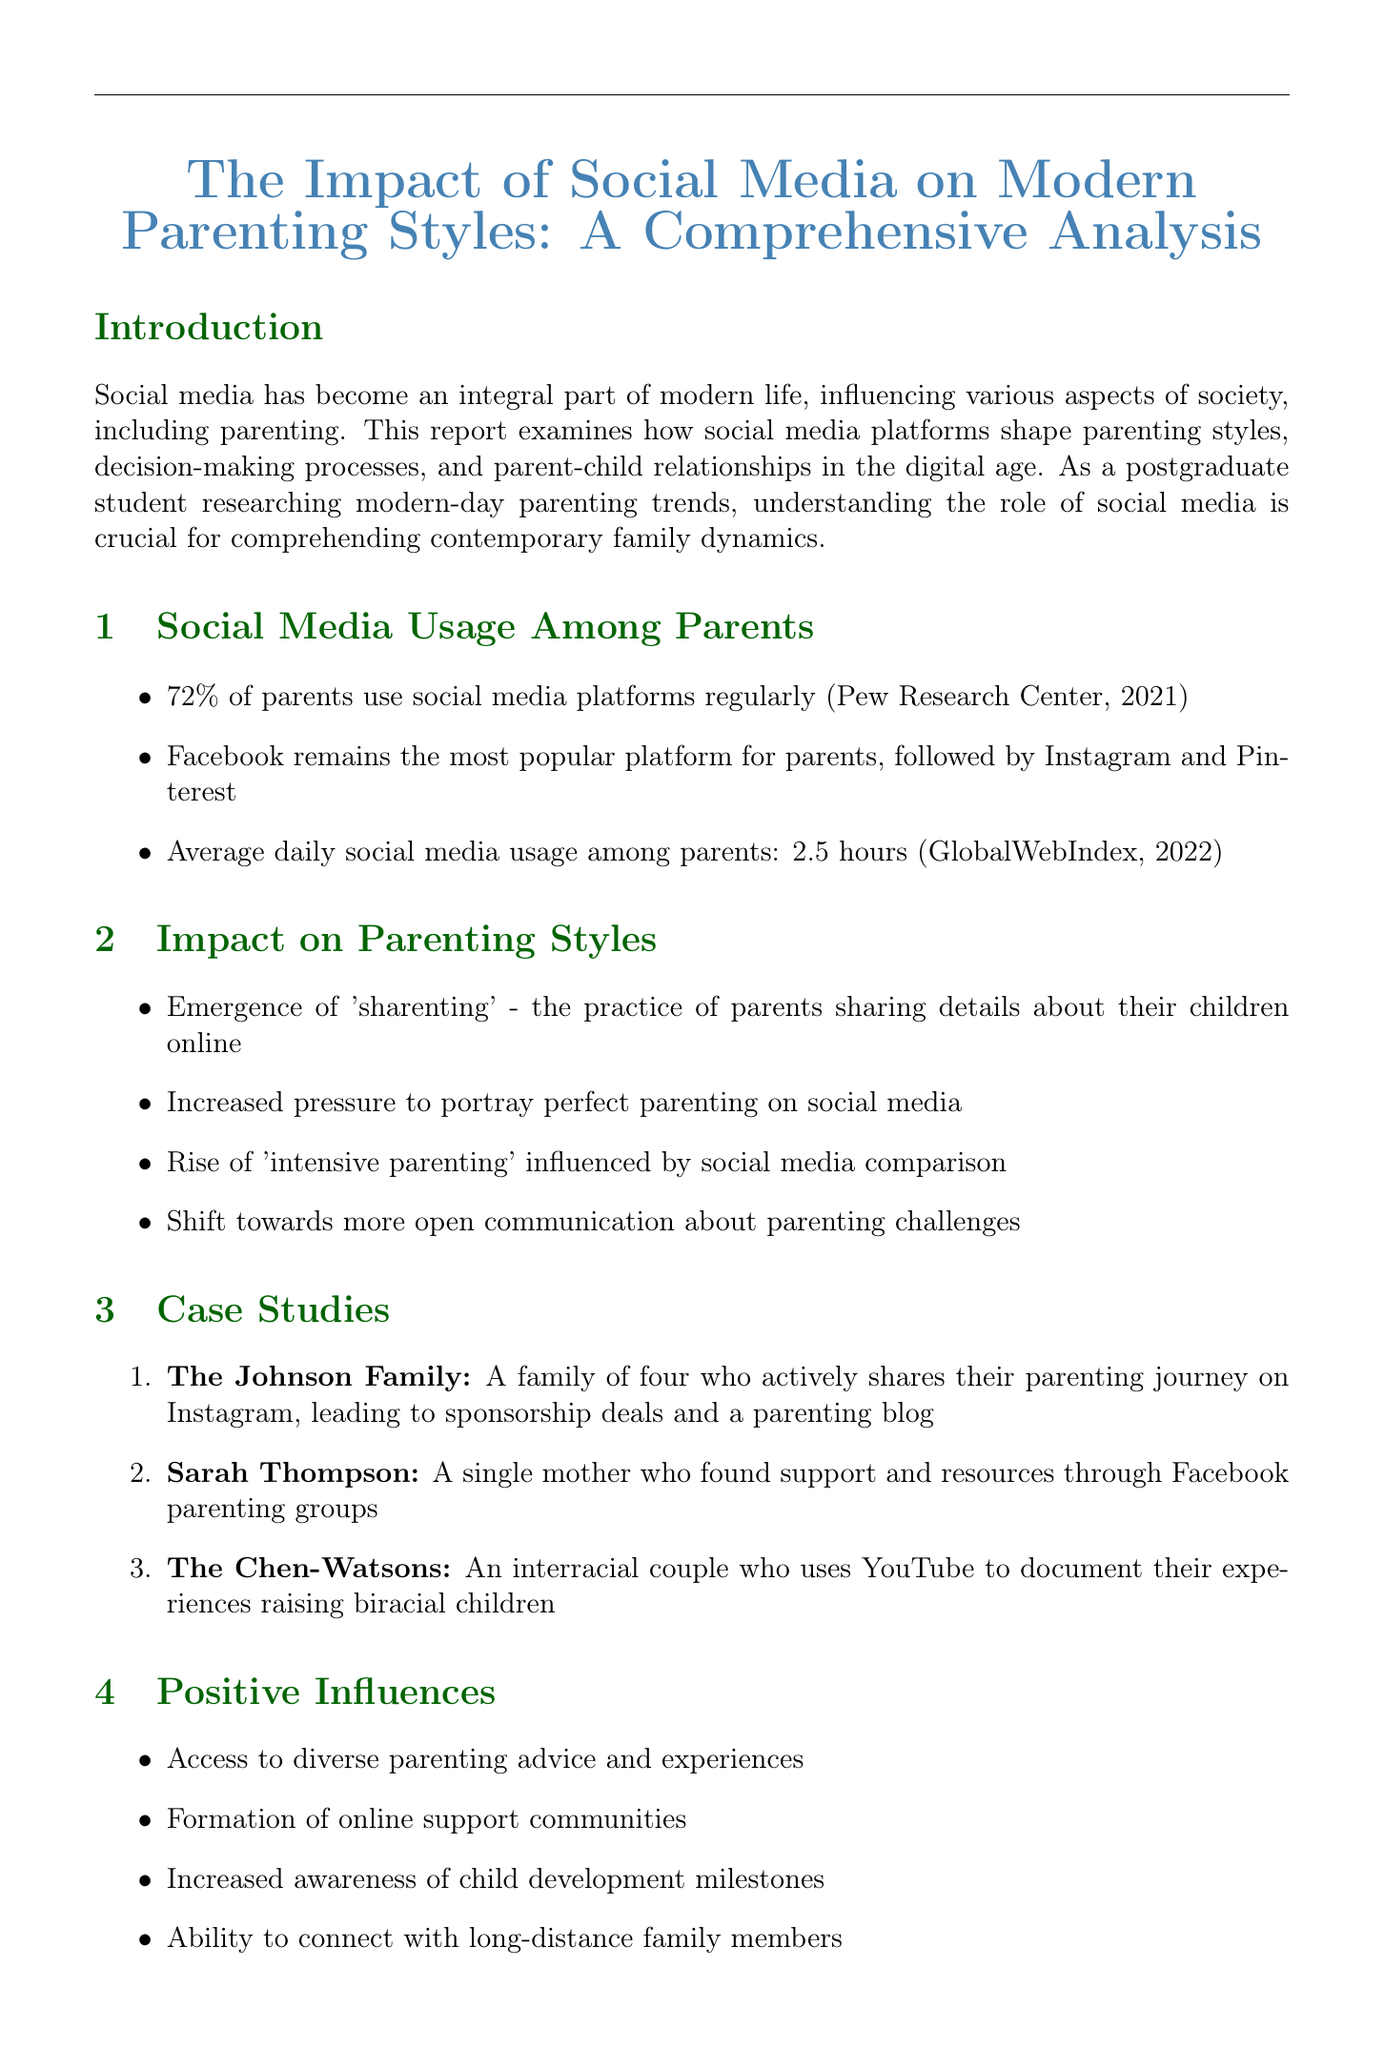What percentage of parents use social media regularly? The report states that 72% of parents use social media platforms regularly according to the Pew Research Center.
Answer: 72% Which social media platform is the most popular among parents? The document mentions that Facebook remains the most popular platform for parents.
Answer: Facebook What is the average daily social media usage among parents? According to the GlobalWebIndex, the average daily usage is 2.5 hours.
Answer: 2.5 hours What percentage of parents feel pressure to present an idealized version of family life online? The OnePoll survey indicates that 42% of parents feel this pressure.
Answer: 42% Who is the expert from Harvard Graduate School of Education quoted in the report? The report features Dr. Emily Weinstein as an expert from Harvard Graduate School of Education.
Answer: Dr. Emily Weinstein What term describes the practice of parents sharing details about their children online? The document refers to this practice as "sharenting."
Answer: sharenting What was the increase in likelihood of parental burnout for frequent social media users? According to the Journal of Social and Personal Relationships, frequent users are 62% more likely to experience parental burnout.
Answer: 62% What is one positive influence of social media mentioned in the report? The document lists access to diverse parenting advice as a positive influence.
Answer: Access to diverse parenting advice How many families were featured in the case studies section? The report outlines three case studies of different families.
Answer: Three 